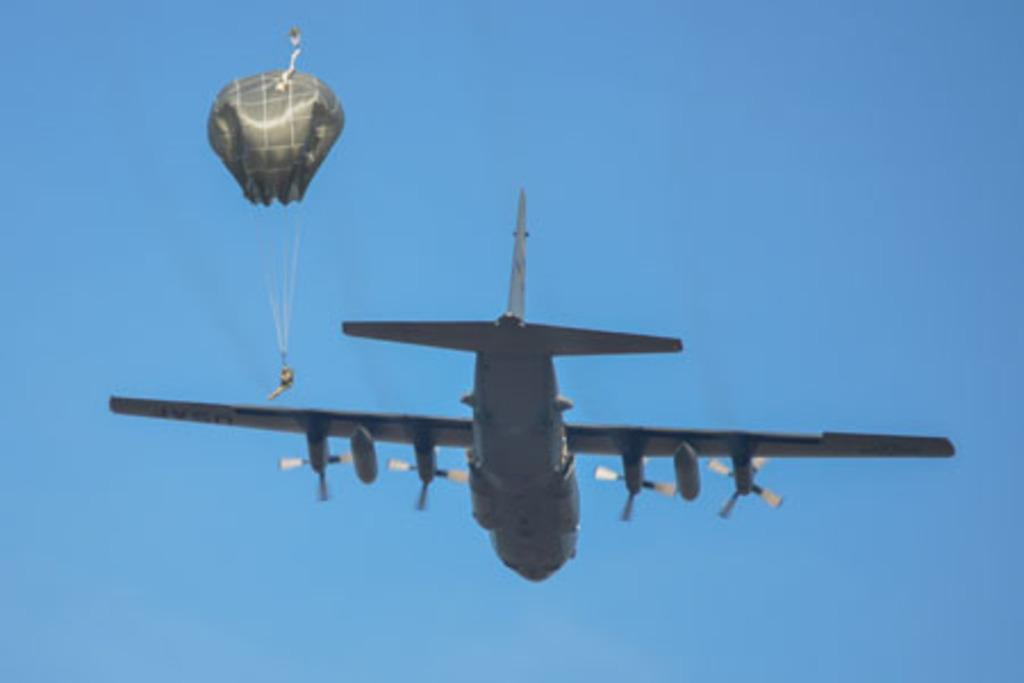What is happening in the sky in the image? There is a plane flying in the air in the image. What is the person beside the plane doing? The person is holding a parachute beside the plane. What type of attention is the person holding the parachute giving to the fear of knowledge in the image? There is no indication of fear or knowledge in the image, as it only features a plane flying in the air and a person holding a parachute. 